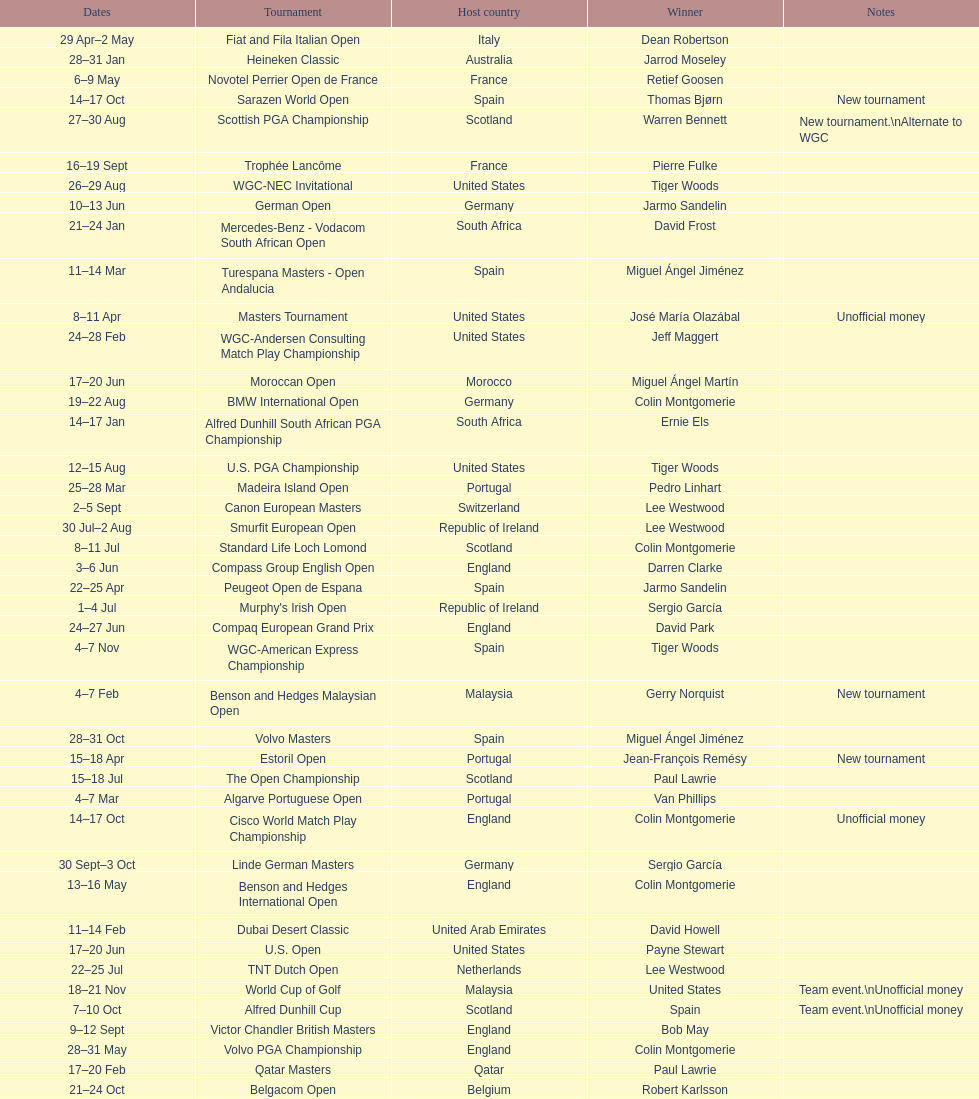What was the country listed the first time there was a new tournament? Malaysia. 